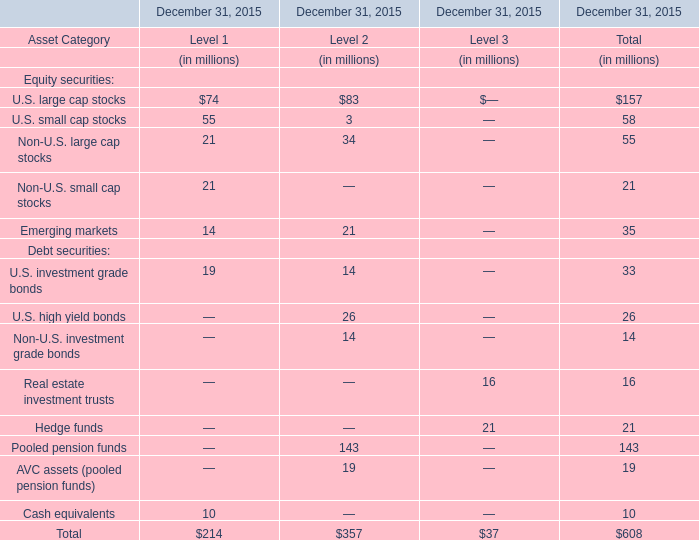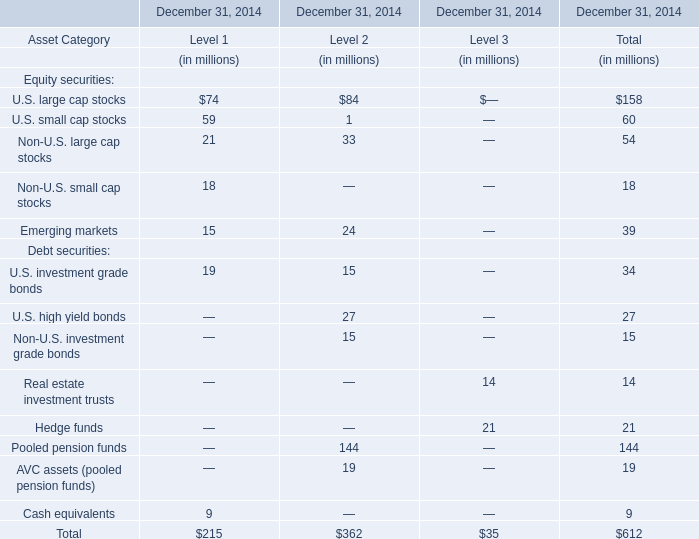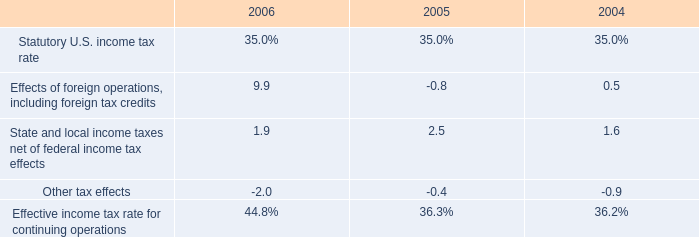What is the proportion of U.S. large cap stocks of Level 1 to the total in2014? (in %) 
Computations: (74 / 215)
Answer: 0.34419. 